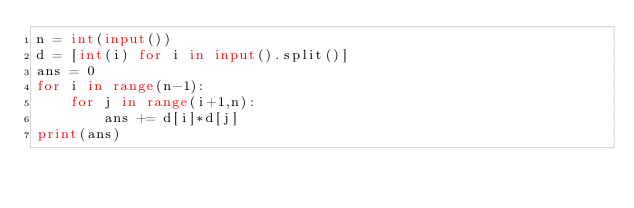Convert code to text. <code><loc_0><loc_0><loc_500><loc_500><_Python_>n = int(input())
d = [int(i) for i in input().split()]
ans = 0
for i in range(n-1):
    for j in range(i+1,n):
        ans += d[i]*d[j]
print(ans)
</code> 